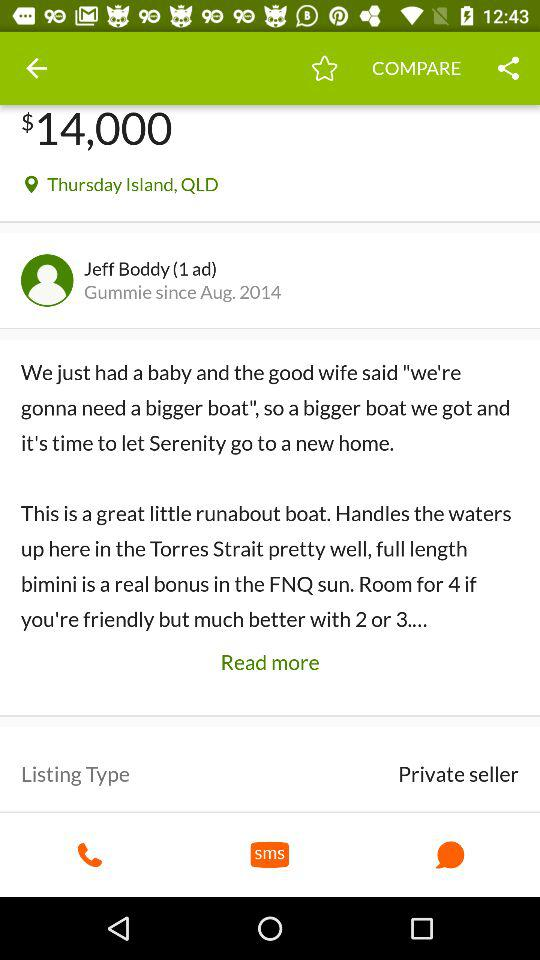What's the location? The location is Thursday Island, Queensland. 